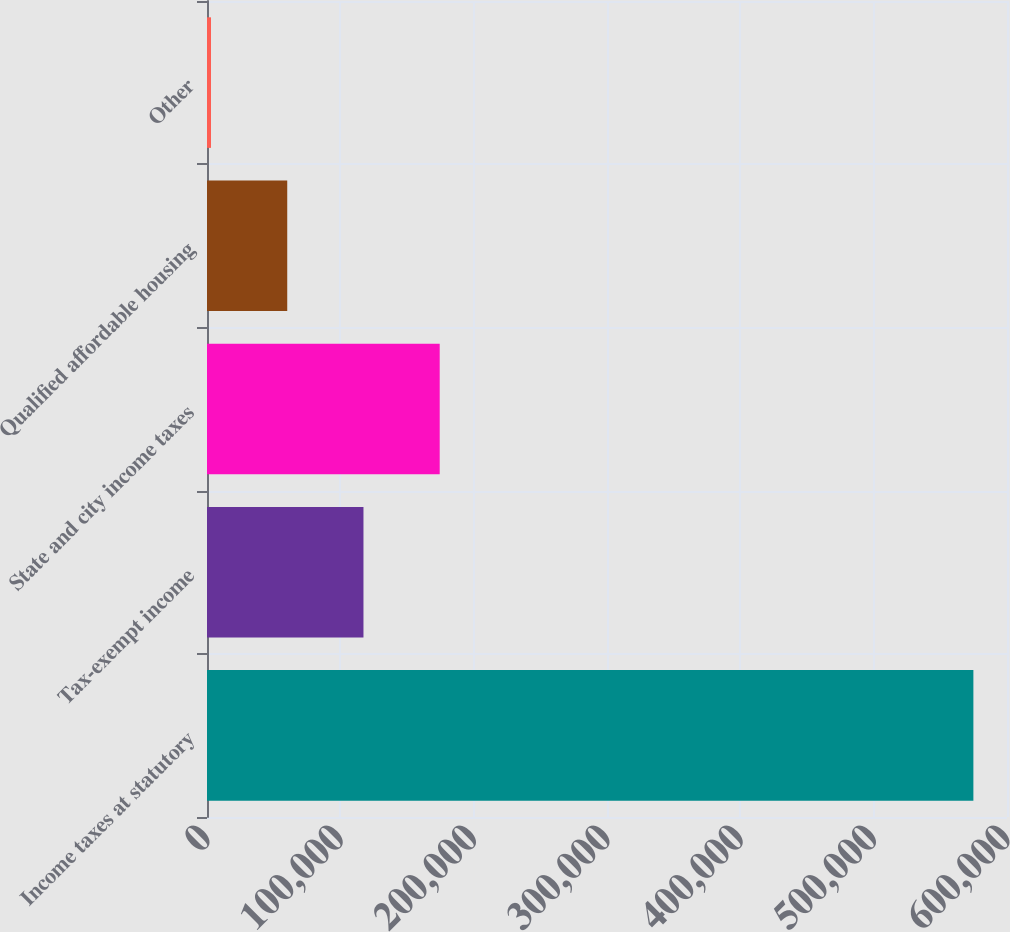Convert chart to OTSL. <chart><loc_0><loc_0><loc_500><loc_500><bar_chart><fcel>Income taxes at statutory<fcel>Tax-exempt income<fcel>State and city income taxes<fcel>Qualified affordable housing<fcel>Other<nl><fcel>574786<fcel>117354<fcel>174533<fcel>60175<fcel>2996<nl></chart> 